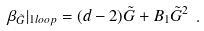Convert formula to latex. <formula><loc_0><loc_0><loc_500><loc_500>\beta _ { \tilde { G } } | _ { 1 l o o p } = ( d - 2 ) \tilde { G } + B _ { 1 } \tilde { G } ^ { 2 } \ .</formula> 